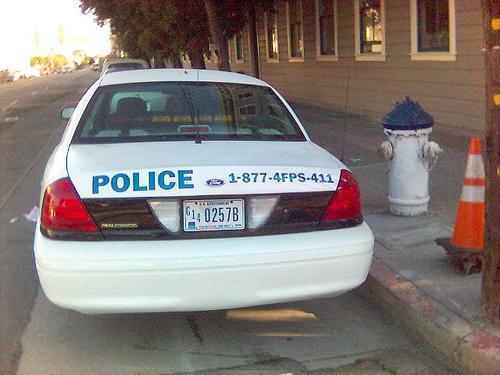How many spots are visible on the hydrant?
Give a very brief answer. 2. How many windows are on the building?
Give a very brief answer. 6. How many characters are in the phone number?
Give a very brief answer. 11. How many cars can you see?
Give a very brief answer. 1. 